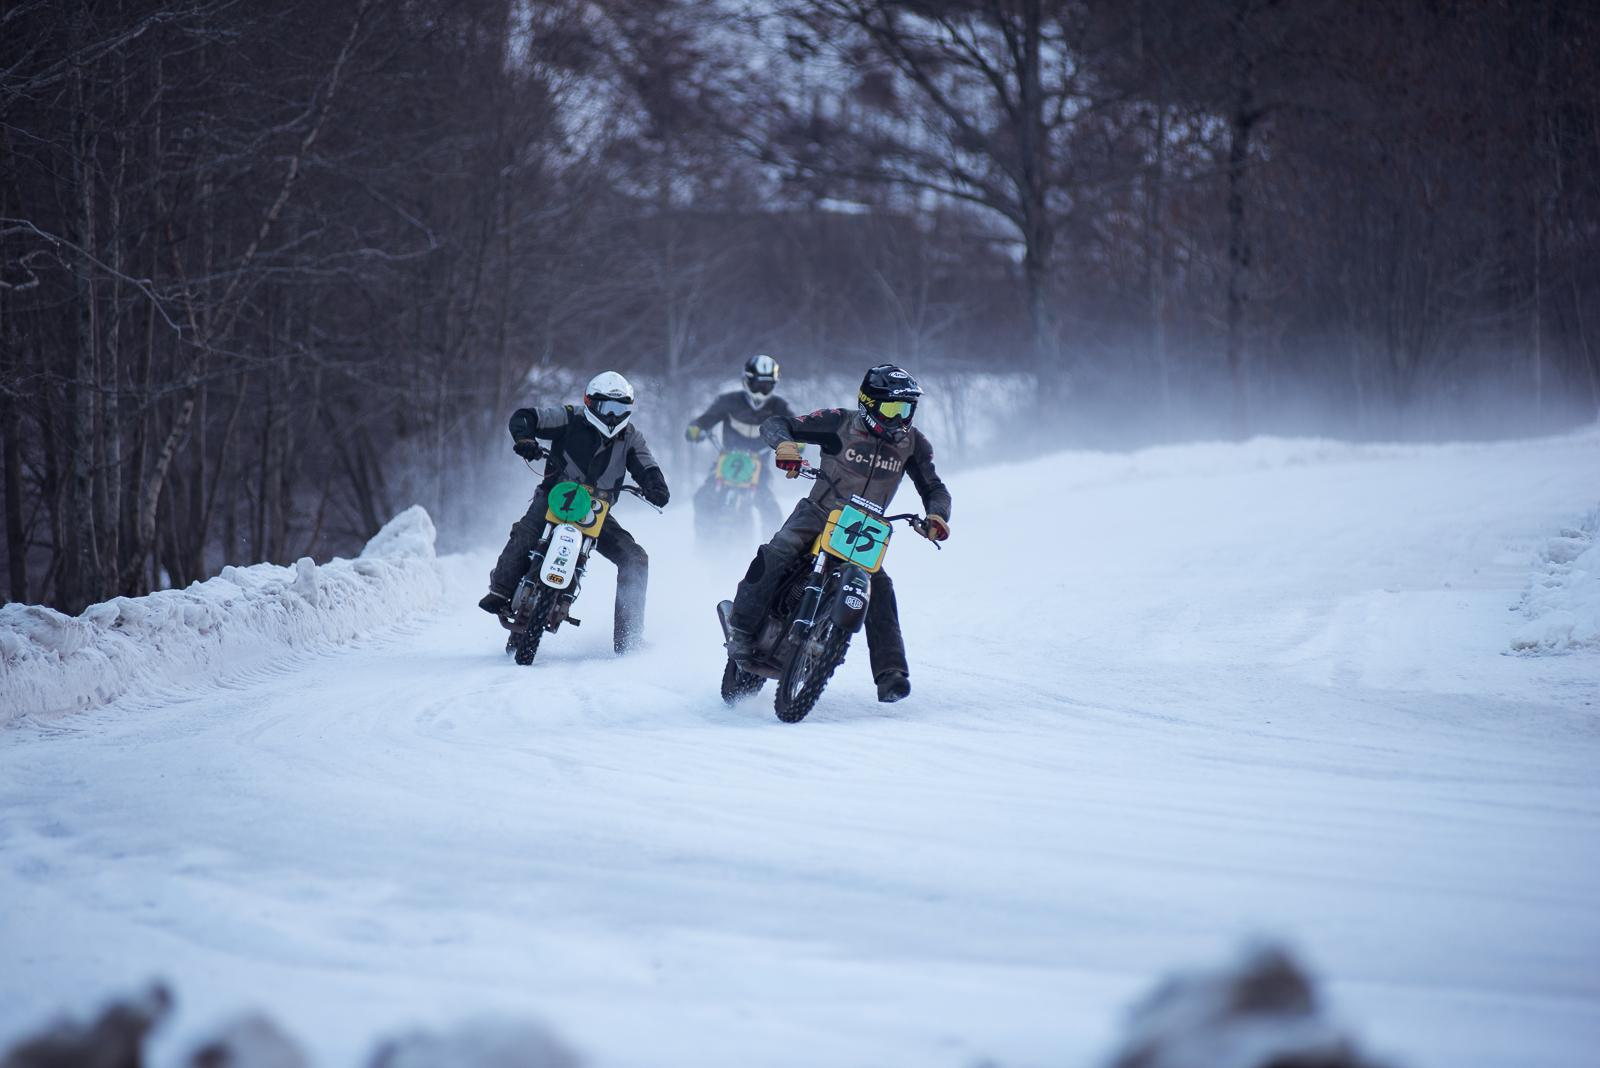How many motorbikes are there in the image? There are three motorbikes in the image, with riders dressed in protective gear, suggesting they are engaged in a motorsport activity, possibly a race or a practice run on a snow-covered track. 